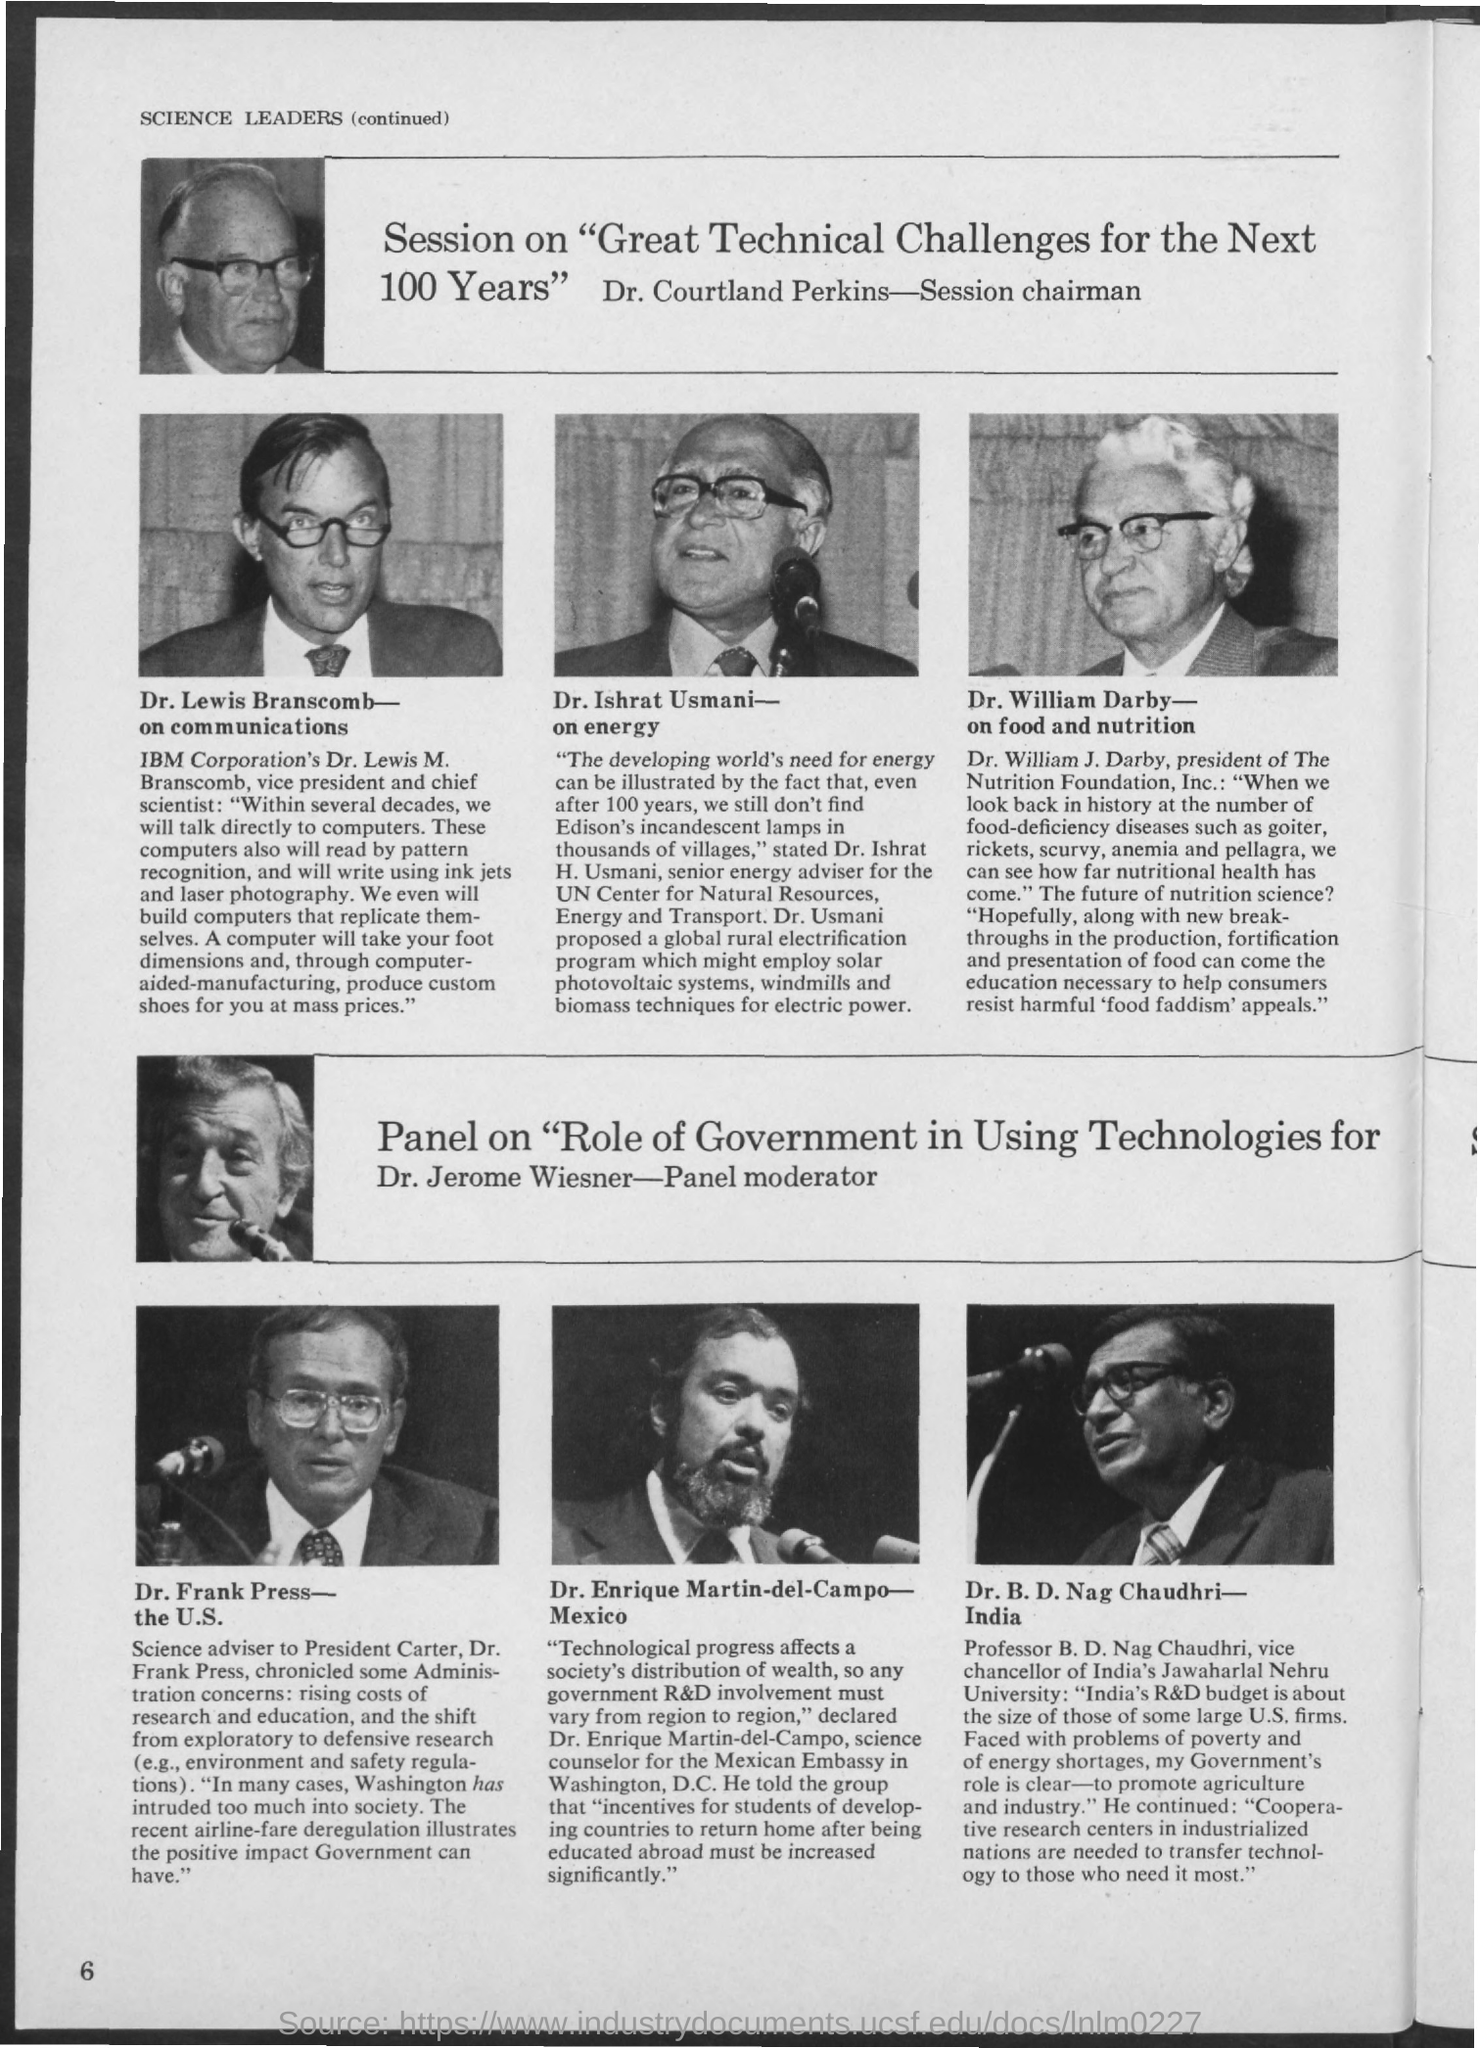Specify some key components in this picture. The speaker announces that the Panel Moderator is Dr. Jerome Wiesner. Dr. Courtland Perkins is the Session Chairman. 